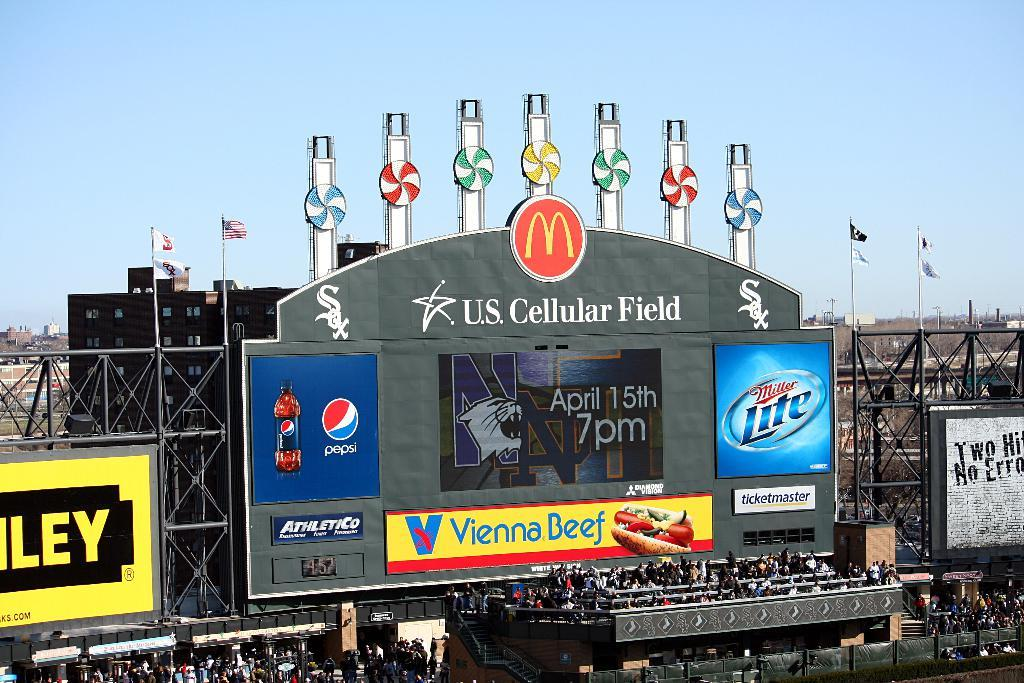Provide a one-sentence caption for the provided image. an outfield sign with a McDonald's advertisement on it. 